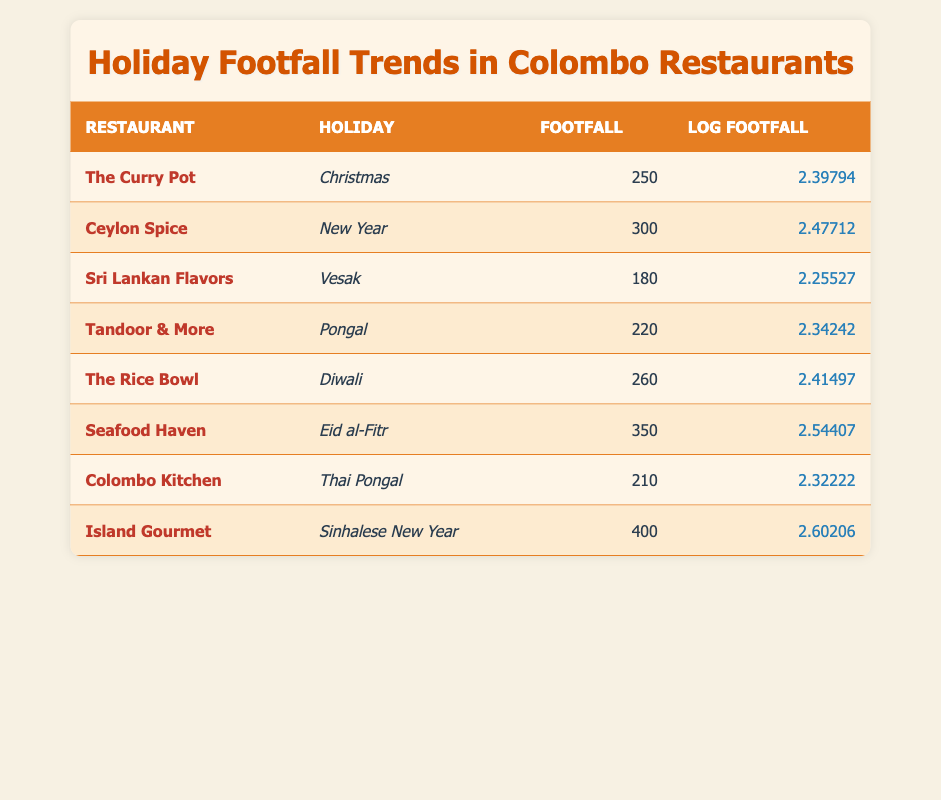What is the footfall for "The Curry Pot" during Christmas? The table shows that the footfall for "The Curry Pot" during Christmas is listed directly under the footfall column. It shows a value of 250.
Answer: 250 Which restaurant had the highest footfall and what was it? By reviewing the footfall values in the table, we can identify that "Island Gourmet" had the highest footfall of 400, marked in the footfall column.
Answer: Island Gourmet, 400 What is the average footfall across all restaurants during the holidays? To find the average footfall, we sum all the footfall values: 250 + 300 + 180 + 220 + 260 + 350 + 210 + 400 = 2070. There are 8 restaurants, so we divide 2070 by 8, giving an average of 258.75.
Answer: 258.75 Is the footfall for "Sri Lankan Flavors" during Vesak greater than the footfall for "Tandoor & More" during Pongal? The footfall for "Sri Lankan Flavors" during Vesak is 180, while the footfall for "Tandoor & More" during Pongal is 220. Since 180 is less than 220, the answer is no.
Answer: No What is the difference in footfall between "Seafood Haven" during Eid al-Fitr and "The Rice Bowl" during Diwali? The footfall for "Seafood Haven" during Eid al-Fitr is 350, and for "The Rice Bowl" during Diwali, it is 260. The difference is calculated by subtracting: 350 - 260 = 90.
Answer: 90 Which holiday had the lowest footfall and what was the value? Analyzing the footfall values across all holidays, "Sri Lankan Flavors" during Vesak had the lowest footfall of 180, as indicated in the footfall column.
Answer: Vesak, 180 How many restaurants had a footfall greater than 300? To find this, we check each restaurant's footfall: "Ceylon Spice" (300), "Seafood Haven" (350), and "Island Gourmet" (400) all exceed 300. Therefore, there are 3 restaurants in total.
Answer: 3 Is it true that the log footfall of "Colombo Kitchen" is greater than that of "Tandoor & More"? The log footfall of "Colombo Kitchen" is 2.32222 and for "Tandoor & More," it's 2.34242. Since 2.32222 is less than 2.34242, this statement is false.
Answer: No What is the combined footfall of all restaurants during Christmas and New Year? The combined footfall includes "The Curry Pot" during Christmas (250) and "Ceylon Spice" during New Year (300). Adding these gives us: 250 + 300 = 550.
Answer: 550 